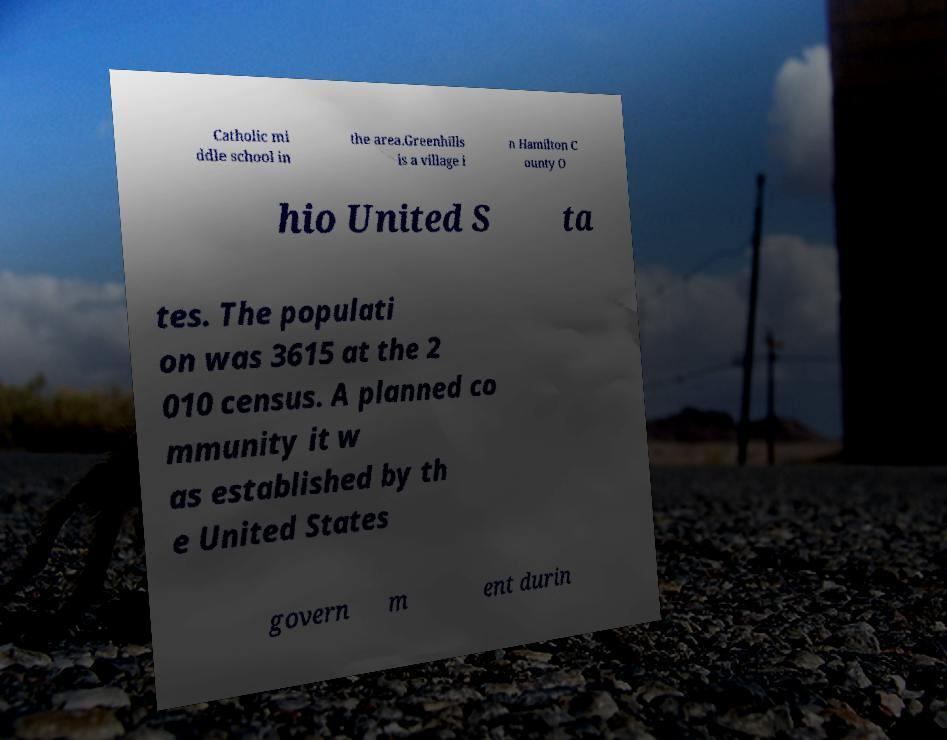There's text embedded in this image that I need extracted. Can you transcribe it verbatim? Catholic mi ddle school in the area.Greenhills is a village i n Hamilton C ounty O hio United S ta tes. The populati on was 3615 at the 2 010 census. A planned co mmunity it w as established by th e United States govern m ent durin 